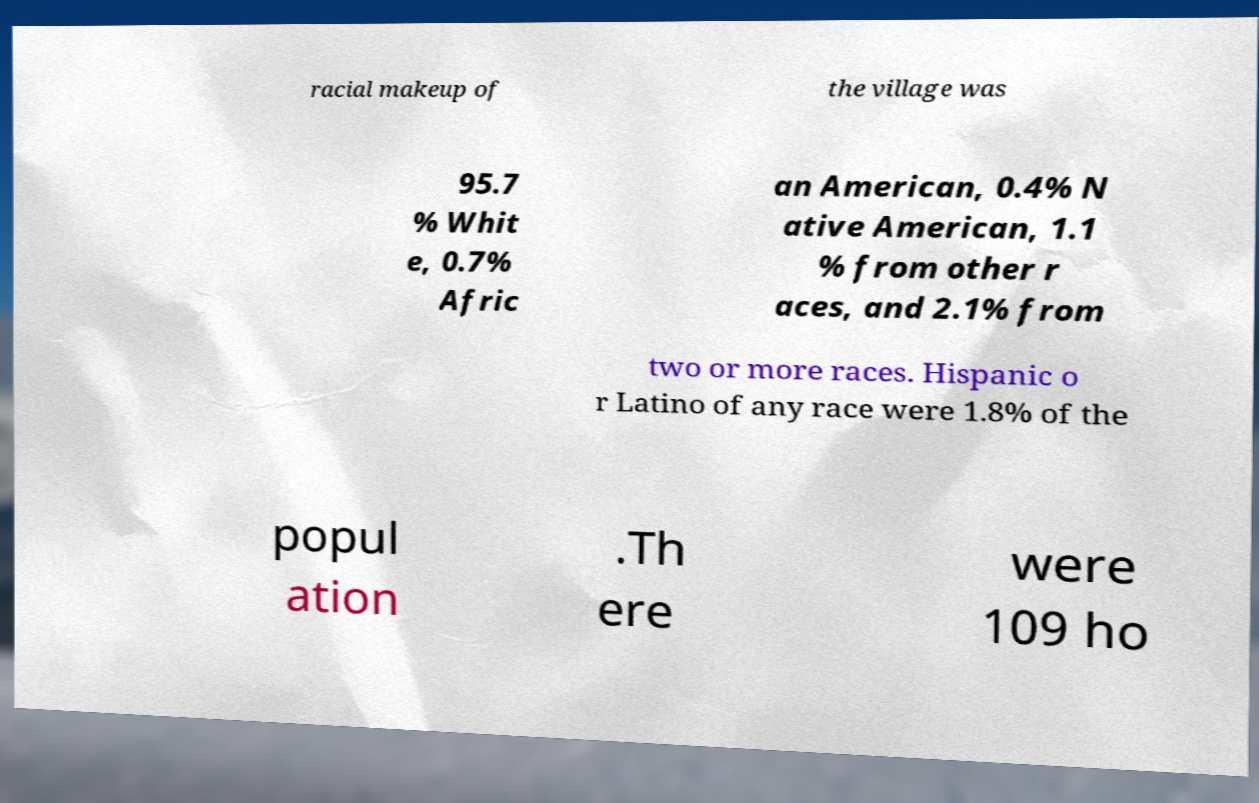Can you accurately transcribe the text from the provided image for me? racial makeup of the village was 95.7 % Whit e, 0.7% Afric an American, 0.4% N ative American, 1.1 % from other r aces, and 2.1% from two or more races. Hispanic o r Latino of any race were 1.8% of the popul ation .Th ere were 109 ho 